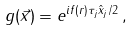<formula> <loc_0><loc_0><loc_500><loc_500>g ( \vec { x } ) = e ^ { i f ( r ) \tau _ { j } \hat { x } _ { j } / 2 } \, ,</formula> 